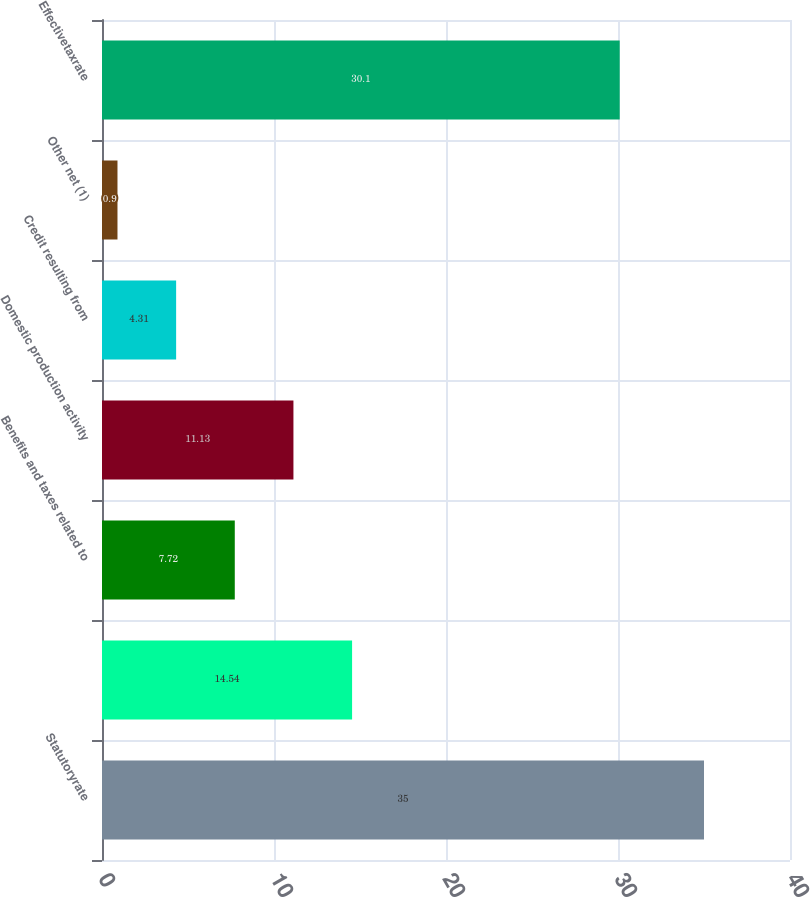<chart> <loc_0><loc_0><loc_500><loc_500><bar_chart><fcel>Statutoryrate<fcel>Unnamed: 1<fcel>Benefits and taxes related to<fcel>Domestic production activity<fcel>Credit resulting from<fcel>Other net (1)<fcel>Effectivetaxrate<nl><fcel>35<fcel>14.54<fcel>7.72<fcel>11.13<fcel>4.31<fcel>0.9<fcel>30.1<nl></chart> 